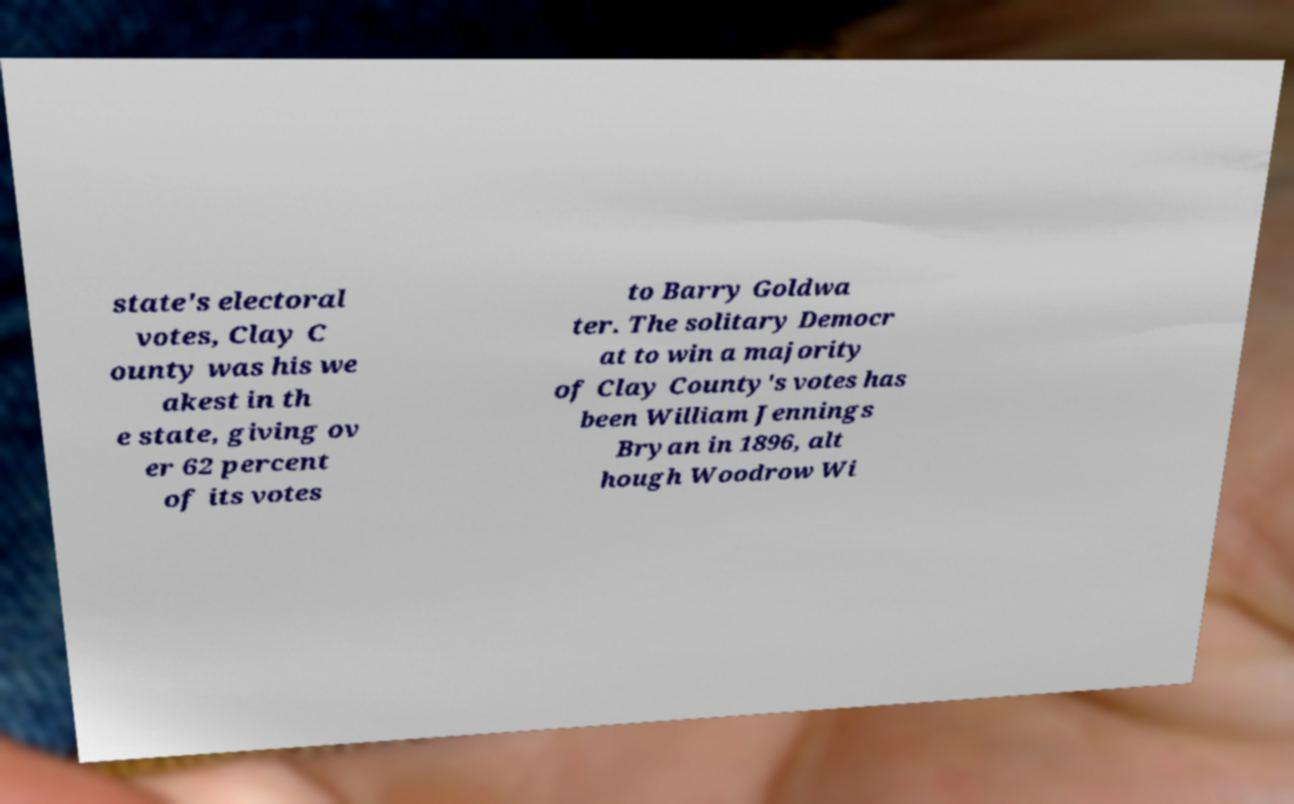Please identify and transcribe the text found in this image. state's electoral votes, Clay C ounty was his we akest in th e state, giving ov er 62 percent of its votes to Barry Goldwa ter. The solitary Democr at to win a majority of Clay County's votes has been William Jennings Bryan in 1896, alt hough Woodrow Wi 